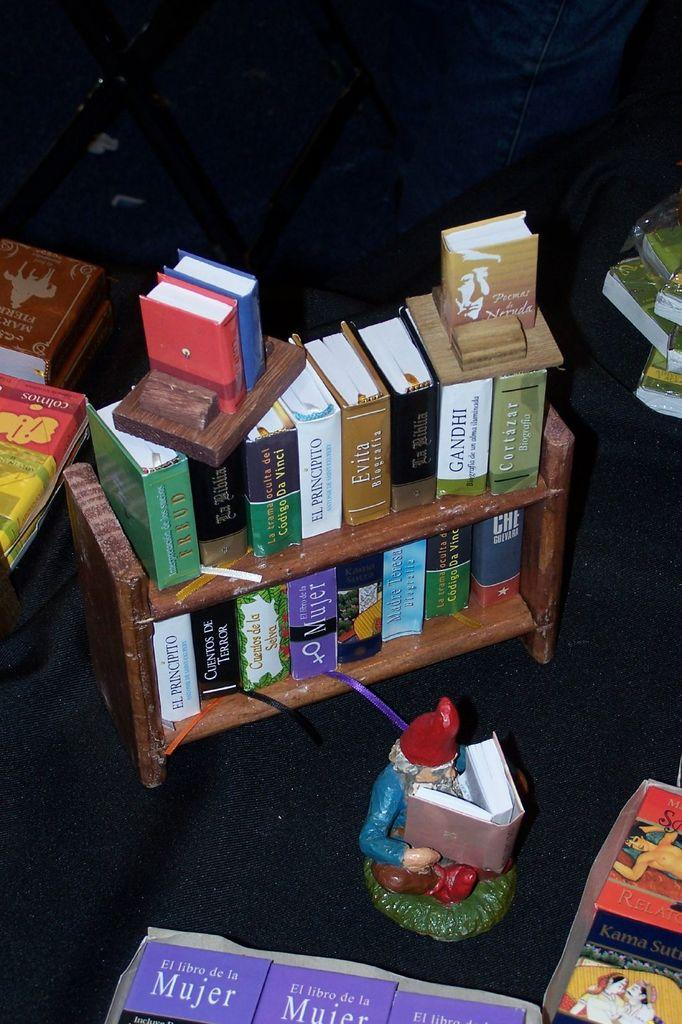<image>
Summarize the visual content of the image. A small book shelf with a figurine in front of it with books about El Librode la Mujer in front of it. 